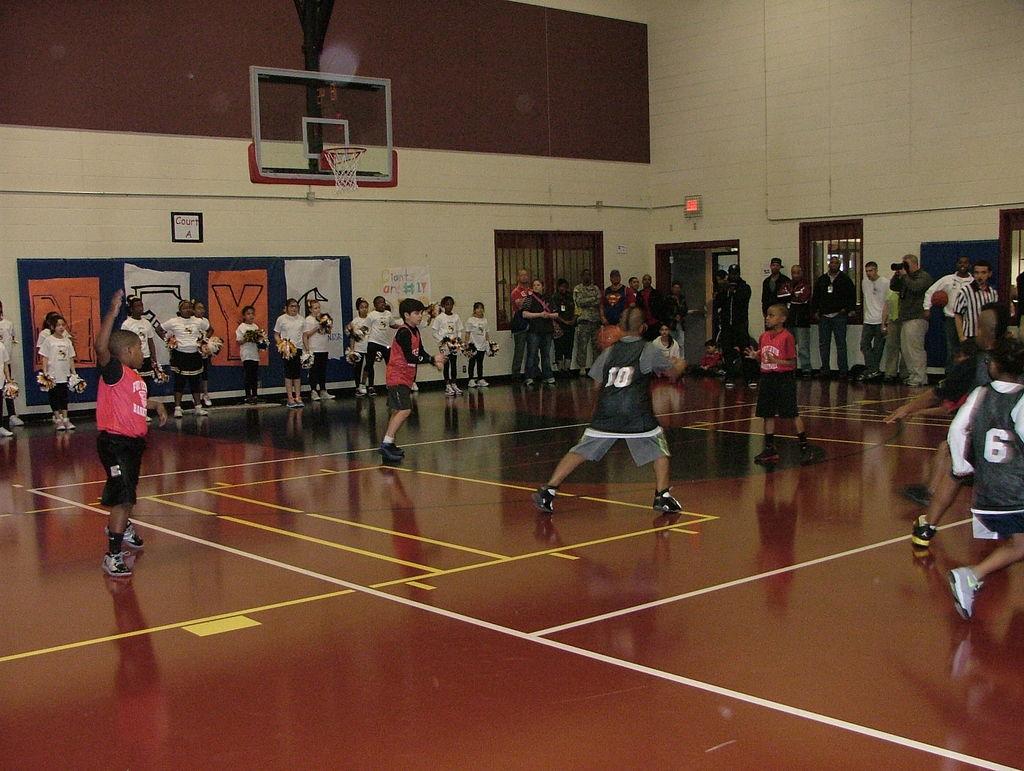What number jersey is the person all the way to the right?
Offer a terse response. 6. Is the number 3 on the front of the boy on the left?
Provide a short and direct response. Yes. 